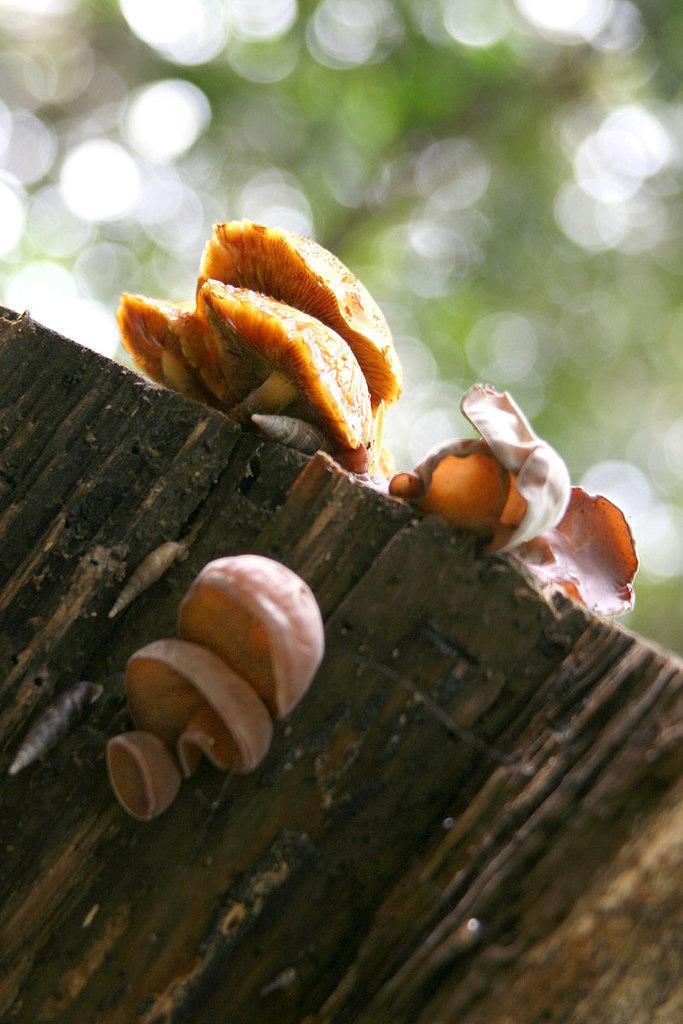In one or two sentences, can you explain what this image depicts? In this image we can see few mushrooms on the wood and in the background the image is blurred. 